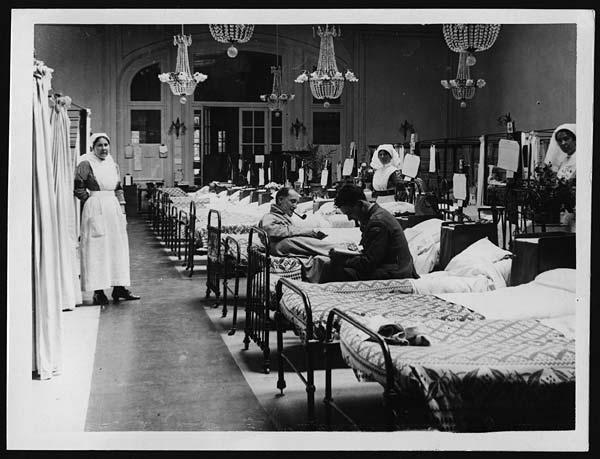How many people can be seen?
Give a very brief answer. 3. How many beds are in the photo?
Give a very brief answer. 4. 